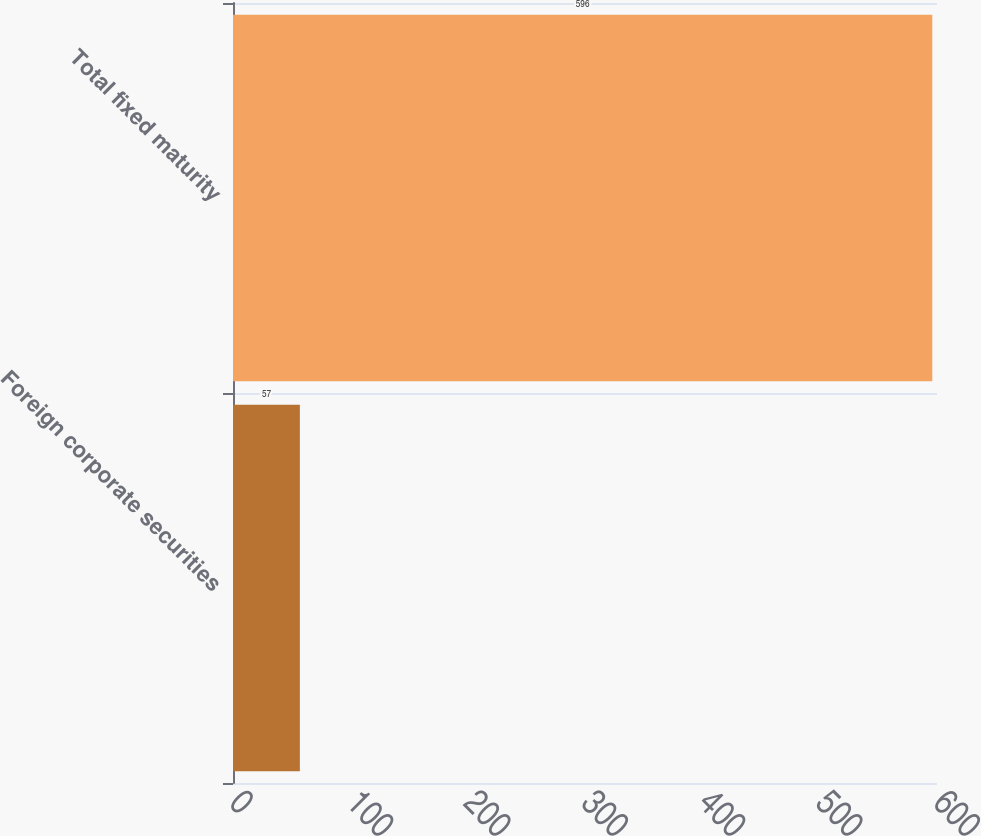<chart> <loc_0><loc_0><loc_500><loc_500><bar_chart><fcel>Foreign corporate securities<fcel>Total fixed maturity<nl><fcel>57<fcel>596<nl></chart> 